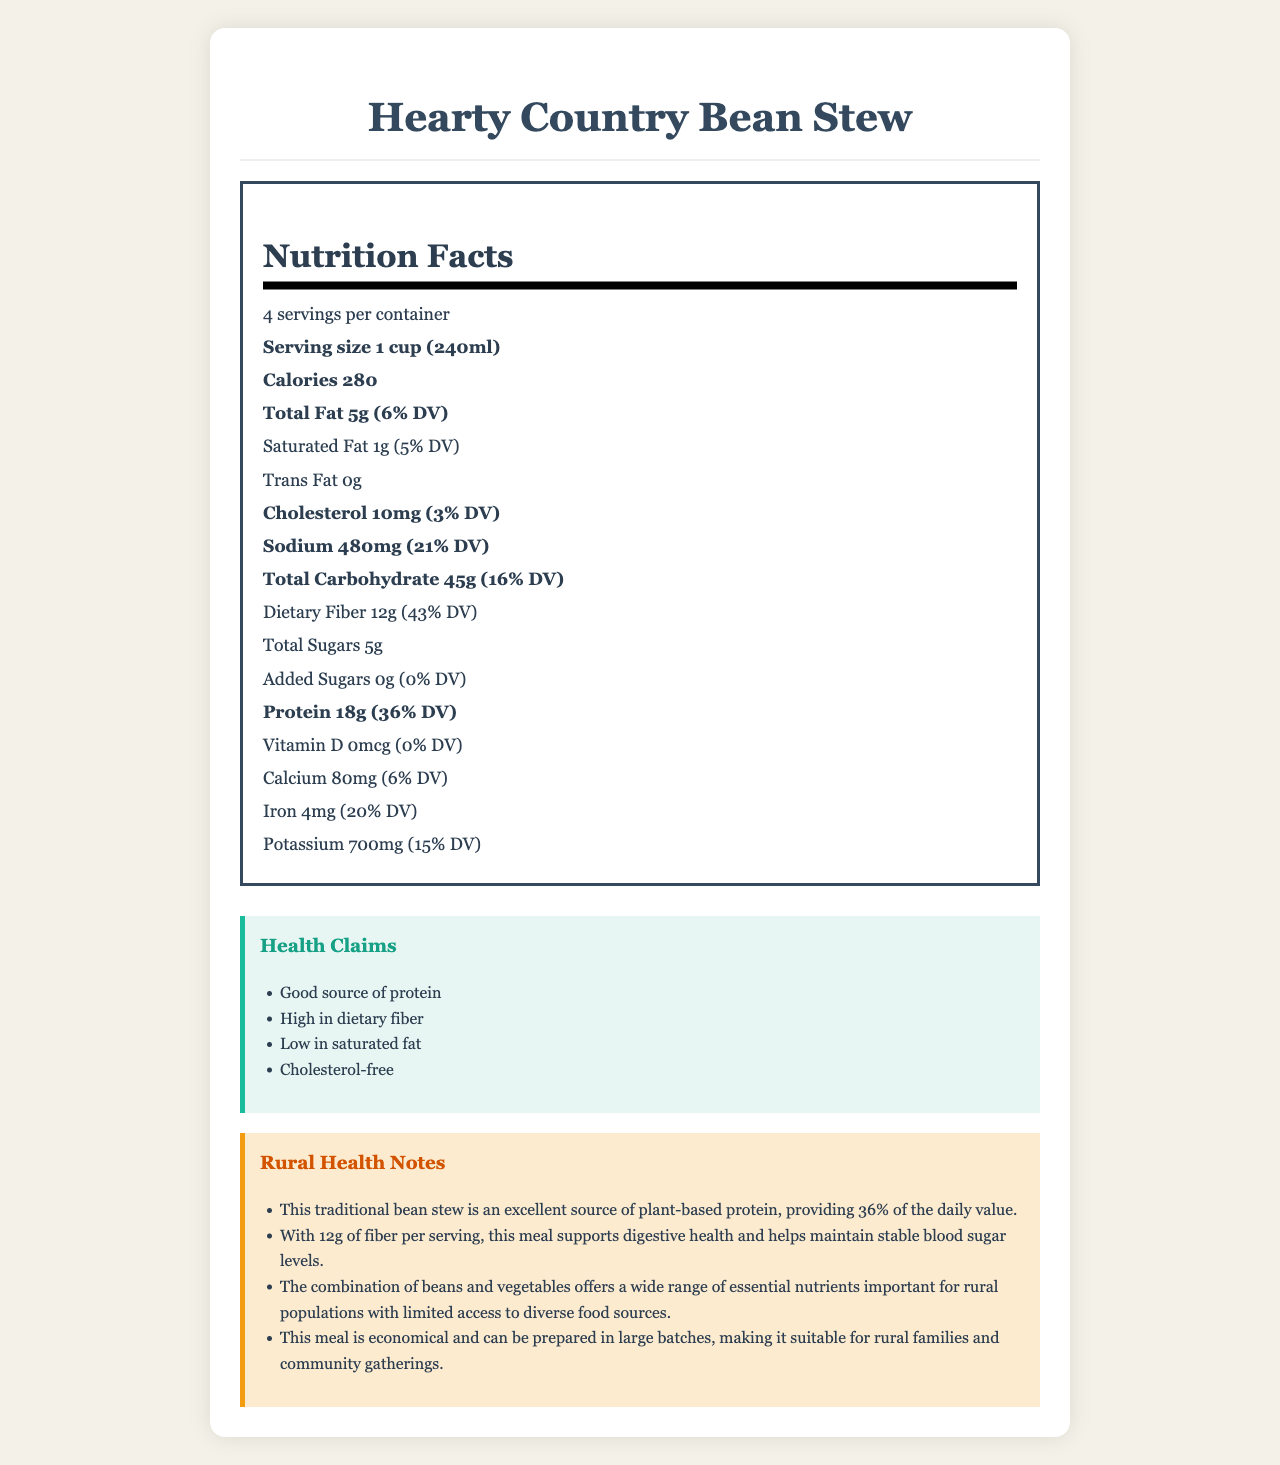what is the serving size for Hearty Country Bean Stew? The serving size is mentioned directly under the product name and servings per container section.
Answer: 1 cup (240ml) how many grams of protein are in one serving? The protein content is explicitly listed in the Nutrition Facts section, showing 18 grams per serving.
Answer: 18g what percentage of the daily value for dietary fiber is provided by one serving? The daily value percentage for dietary fiber is given directly as 43% in the Nutrition Facts section.
Answer: 43% how many servings are there per container? The document states there are 4 servings per container, indicated just below the product name and serving size section.
Answer: 4 what are the main ingredients in the Hearty Country Bean Stew? The list of ingredients is provided in the Ingredients section of the document.
Answer: Pinto beans, Black beans, Diced tomatoes, Onions, Bell peppers, Carrots, Garlic, Olive oil, Vegetable broth, Cumin, Chili powder, Salt, Black pepper which of the following is a health claim made about this product? A. High in sodium B. High in dietary fiber C. Contains saturated fat The health claims section mentions that the product is high in dietary fiber.
Answer: B how much potassium is in one serving? A. 700mg B. 480mg C. 80mg D. 4mg The Nutrition Facts section indicates that one serving of the product contains 700mg of potassium.
Answer: A is this product cholesterol-free? The Nutrition Facts section lists 10mg of cholesterol per serving, so it is not cholesterol-free.
Answer: No does this meal support digestive health? The Rural Health Notes mention that with 12g of fiber per serving, this meal supports digestive health.
Answer: Yes is the Hearty Country Bean Stew high in added sugars? The Nutrition Facts section shows that the amount of added sugars is 0g, which means it has no added sugars.
Answer: No how much preparation is required for the Hearty Country Bean Stew? The preparation instructions clearly state that the product just needs to be heated and served.
Answer: Heat and serve. describe the main idea of the document. The document consists of detailed sections including serving size, servings per container, calories, and various nutrients. It also emphasizes the product's health benefits like being a good source of protein and fiber, and practical notes for rural populations.
Answer: The document provides detailed nutritional information, health claims, and rural health notes for Hearty Country Bean Stew. It highlights the meal's significant protein and fiber content, making it a nutritious and economical option suitable for rural environments, with emphasis on being plant-based, high in dietary fiber, and low in saturated fat. how many grams of total fat are in the entire container? The document provides the total fat content per serving (5g), but doesn't directly provide the information for the entire container without additional calculation.
Answer: Cannot be determined 